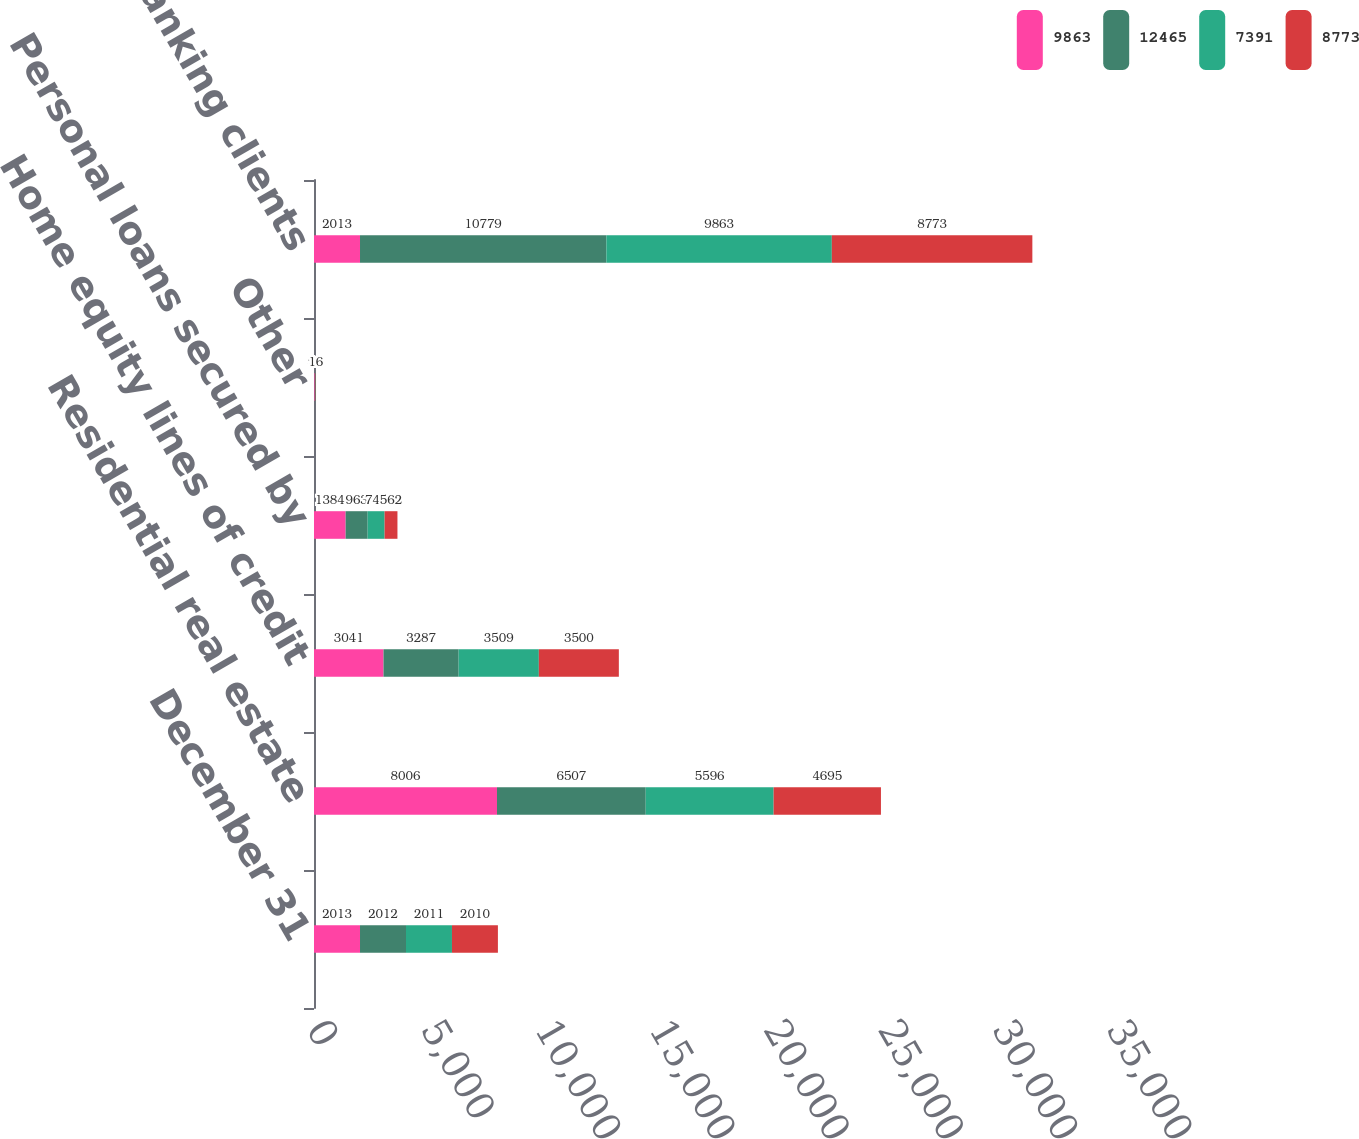<chart> <loc_0><loc_0><loc_500><loc_500><stacked_bar_chart><ecel><fcel>December 31<fcel>Residential real estate<fcel>Home equity lines of credit<fcel>Personal loans secured by<fcel>Other<fcel>Total loans to banking clients<nl><fcel>9863<fcel>2013<fcel>8006<fcel>3041<fcel>1384<fcel>34<fcel>2013<nl><fcel>12465<fcel>2012<fcel>6507<fcel>3287<fcel>963<fcel>22<fcel>10779<nl><fcel>7391<fcel>2011<fcel>5596<fcel>3509<fcel>742<fcel>16<fcel>9863<nl><fcel>8773<fcel>2010<fcel>4695<fcel>3500<fcel>562<fcel>16<fcel>8773<nl></chart> 